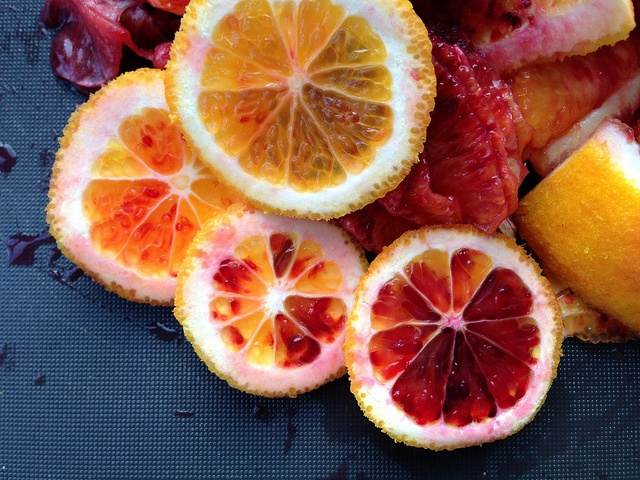Describe the objects in this image and their specific colors. I can see a orange in blue, lightgray, red, and orange tones in this image. 